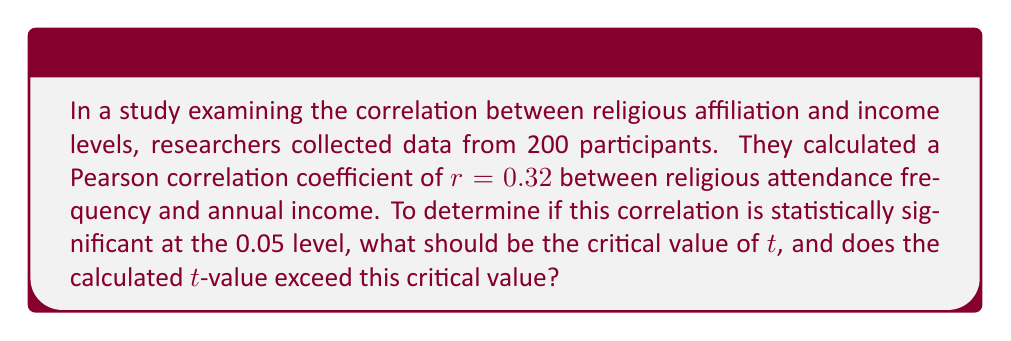Solve this math problem. To determine the statistical significance of the correlation, we need to follow these steps:

1. Calculate the degrees of freedom (df):
   $df = n - 2 = 200 - 2 = 198$

2. Find the critical t-value for a two-tailed test at α = 0.05 with df = 198:
   Using a t-distribution table or calculator, we find $t_{critical} = ±1.972$

3. Calculate the t-value for the correlation:
   $$t = \frac{r\sqrt{n-2}}{\sqrt{1-r^2}}$$
   where r is the correlation coefficient and n is the sample size.

   $$t = \frac{0.32\sqrt{200-2}}{\sqrt{1-0.32^2}}$$
   $$t = \frac{0.32\sqrt{198}}{\sqrt{0.8976}}$$
   $$t = \frac{0.32 * 14.071}{0.9474}$$
   $$t = 4.756$$

4. Compare the calculated t-value to the critical t-value:
   $|4.756| > 1.972$

Since the absolute value of the calculated t-value (4.756) is greater than the critical t-value (1.972), we conclude that the correlation is statistically significant at the 0.05 level.
Answer: $t_{critical} = ±1.972$; Calculated $|t| = 4.756 > t_{critical}$, so the correlation is statistically significant. 